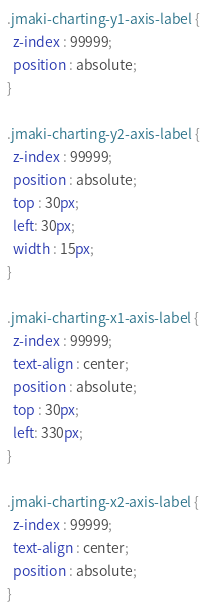<code> <loc_0><loc_0><loc_500><loc_500><_CSS_>.jmaki-charting-y1-axis-label {
  z-index : 99999;
  position : absolute;
}

.jmaki-charting-y2-axis-label {
  z-index : 99999;
  position : absolute;
  top : 30px;
  left: 30px;
  width : 15px;
}

.jmaki-charting-x1-axis-label {
  z-index : 99999;
  text-align : center;
  position : absolute;
  top : 30px;
  left: 330px;
}

.jmaki-charting-x2-axis-label {
  z-index : 99999;
  text-align : center;
  position : absolute;
}</code> 